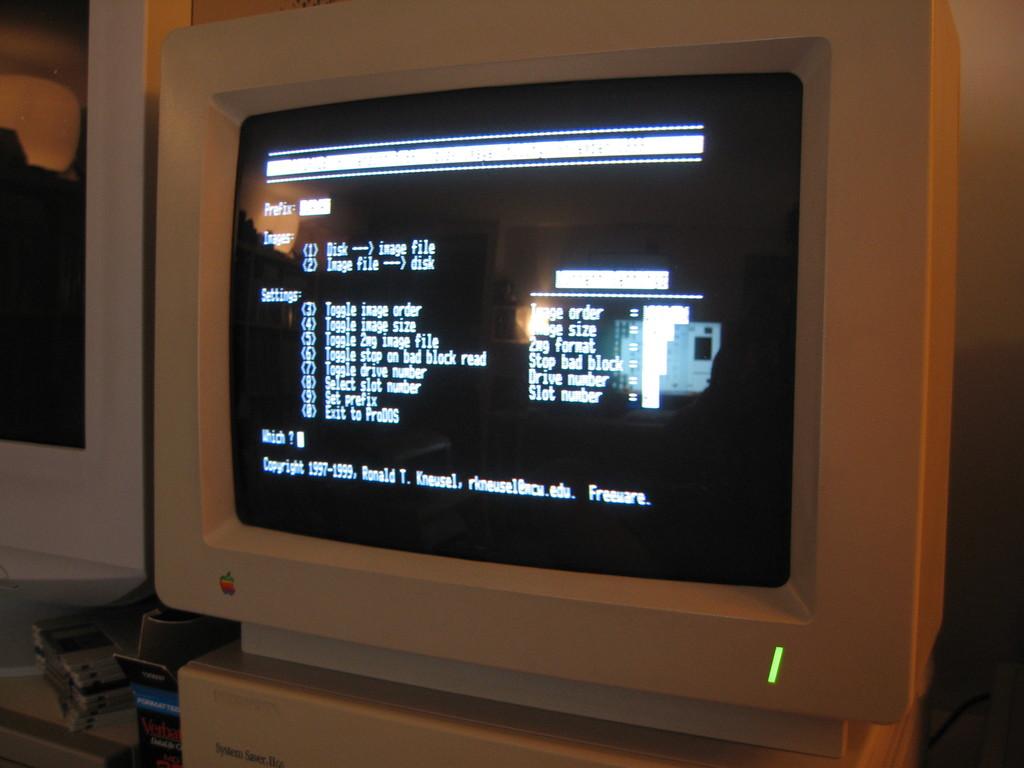What is the copyright year?
Your answer should be very brief. 1997-1999. 